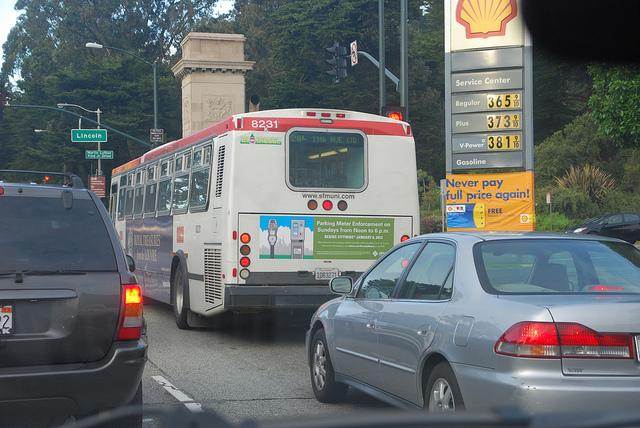What does the business sell? Please explain your reasoning. gas. The sign has a royal dutch shell logo. prices per gallon are below the logo. 